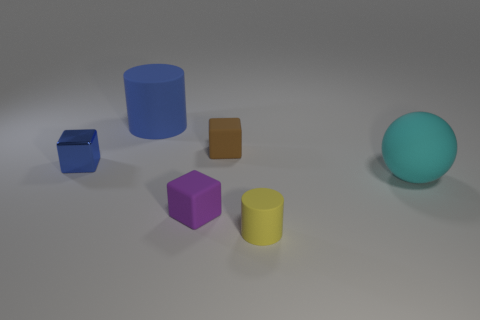What material is the cylinder that is the same color as the tiny shiny object?
Offer a terse response. Rubber. There is a tiny matte object that is both in front of the tiny blue metallic cube and to the right of the small purple matte object; what shape is it?
Offer a very short reply. Cylinder. Is the number of tiny blocks greater than the number of big blue rubber cylinders?
Your answer should be compact. Yes. What is the material of the big blue object?
Provide a succinct answer. Rubber. Are there any other things that are the same size as the yellow object?
Ensure brevity in your answer.  Yes. There is a blue metal thing that is the same shape as the tiny brown rubber object; what is its size?
Offer a very short reply. Small. Are there any metallic blocks that are left of the large object on the left side of the tiny yellow object?
Your answer should be compact. Yes. Is the shiny block the same color as the big rubber sphere?
Keep it short and to the point. No. How many other objects are there of the same shape as the tiny yellow object?
Your answer should be compact. 1. Are there more big balls that are on the left side of the brown thing than cyan matte objects to the left of the purple cube?
Offer a very short reply. No. 